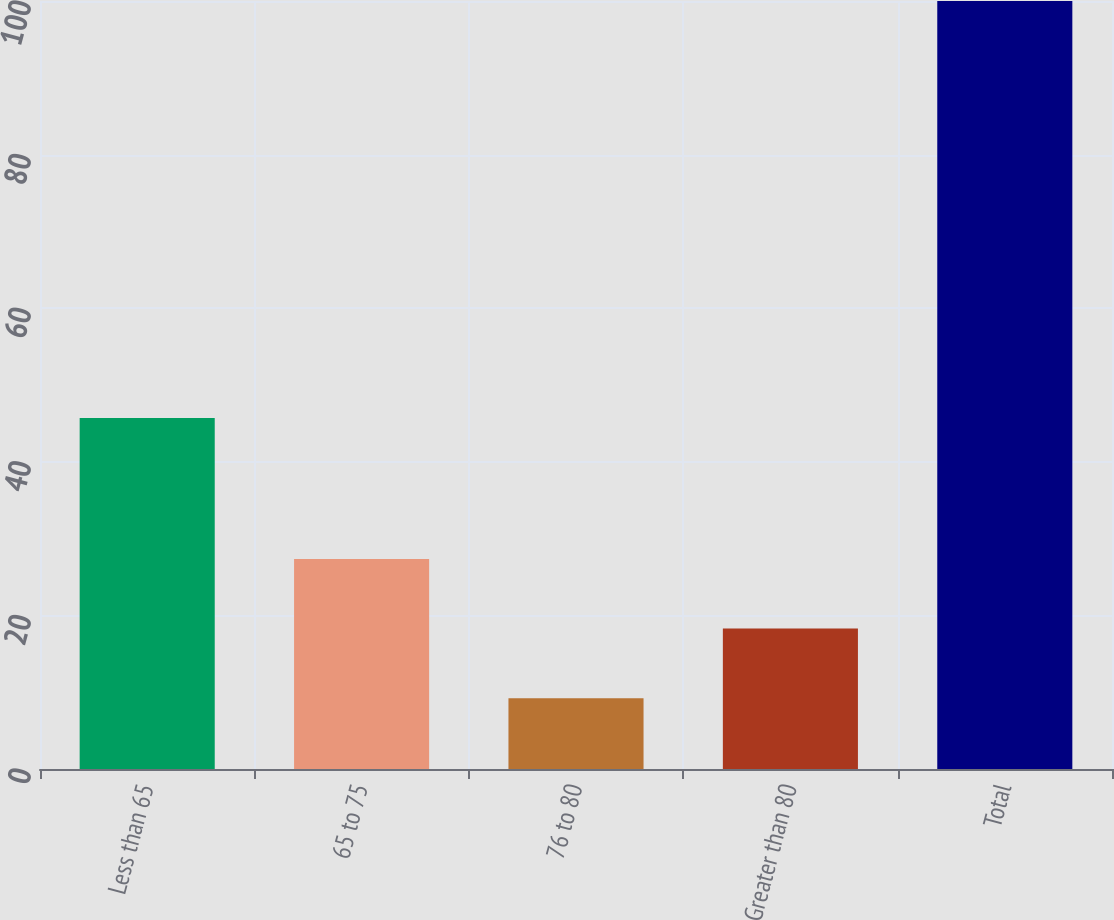<chart> <loc_0><loc_0><loc_500><loc_500><bar_chart><fcel>Less than 65<fcel>65 to 75<fcel>76 to 80<fcel>Greater than 80<fcel>Total<nl><fcel>45.7<fcel>27.36<fcel>9.2<fcel>18.28<fcel>100<nl></chart> 